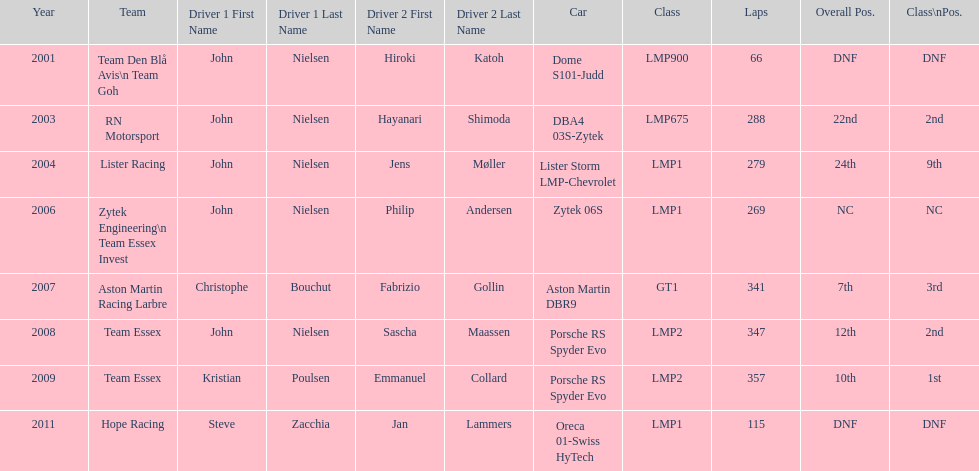In 2008 and what other year was casper elgaard on team essex for the 24 hours of le mans? 2009. 